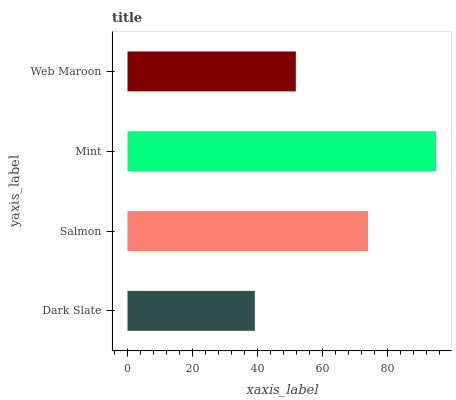Is Dark Slate the minimum?
Answer yes or no. Yes. Is Mint the maximum?
Answer yes or no. Yes. Is Salmon the minimum?
Answer yes or no. No. Is Salmon the maximum?
Answer yes or no. No. Is Salmon greater than Dark Slate?
Answer yes or no. Yes. Is Dark Slate less than Salmon?
Answer yes or no. Yes. Is Dark Slate greater than Salmon?
Answer yes or no. No. Is Salmon less than Dark Slate?
Answer yes or no. No. Is Salmon the high median?
Answer yes or no. Yes. Is Web Maroon the low median?
Answer yes or no. Yes. Is Mint the high median?
Answer yes or no. No. Is Mint the low median?
Answer yes or no. No. 